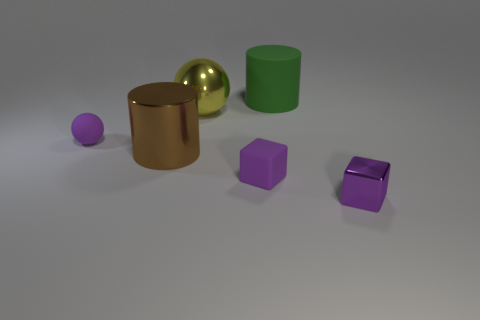Add 2 yellow metal spheres. How many objects exist? 8 Subtract all cylinders. How many objects are left? 4 Subtract all small metallic cubes. Subtract all tiny objects. How many objects are left? 2 Add 2 rubber spheres. How many rubber spheres are left? 3 Add 6 gray matte cubes. How many gray matte cubes exist? 6 Subtract 0 cyan cylinders. How many objects are left? 6 